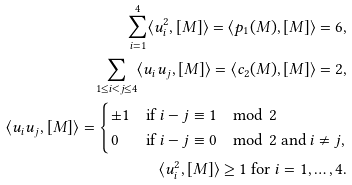<formula> <loc_0><loc_0><loc_500><loc_500>\sum _ { i = 1 } ^ { 4 } \langle u _ { i } ^ { 2 } , [ M ] \rangle = \langle p _ { 1 } ( M ) , [ M ] \rangle = 6 , \\ \sum _ { 1 \leq i < j \leq 4 } \langle u _ { i } u _ { j } , [ M ] \rangle = \langle c _ { 2 } ( M ) , [ M ] \rangle = 2 , \\ \langle u _ { i } u _ { j } , [ M ] \rangle = \begin{cases} \pm 1 & \text {if } i - j \equiv 1 \mod 2 \\ 0 & \text {if } i - j \equiv 0 \mod 2 \text { and } i \neq j , \end{cases} \\ \langle u _ { i } ^ { 2 } , [ M ] \rangle \geq 1 \text { for } i = 1 , \dots , 4 .</formula> 